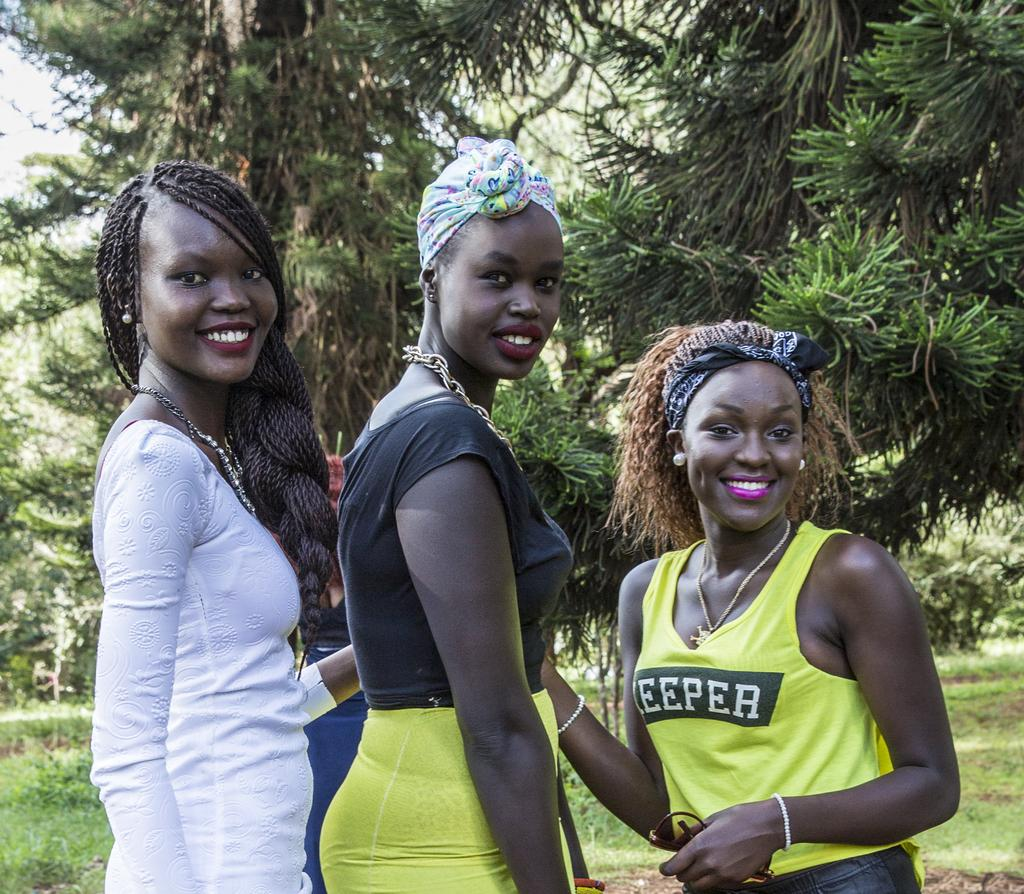How many people are in the foreground of the image? There are three people in the foreground of the image. What expressions do the people have? The people are smiling. What can be seen in the background of the image? There are trees in the background of the image. What type of vegetation is visible in the image? Green grass is visible in the image. What shape is the dust forming in the image? There is no dust present in the image, so it cannot form any shape. 